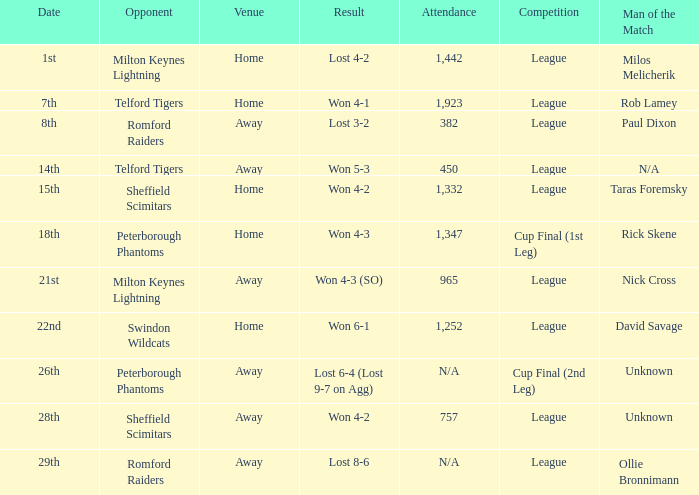What rivalry event was conducted on the 26th? Cup Final (2nd Leg). 